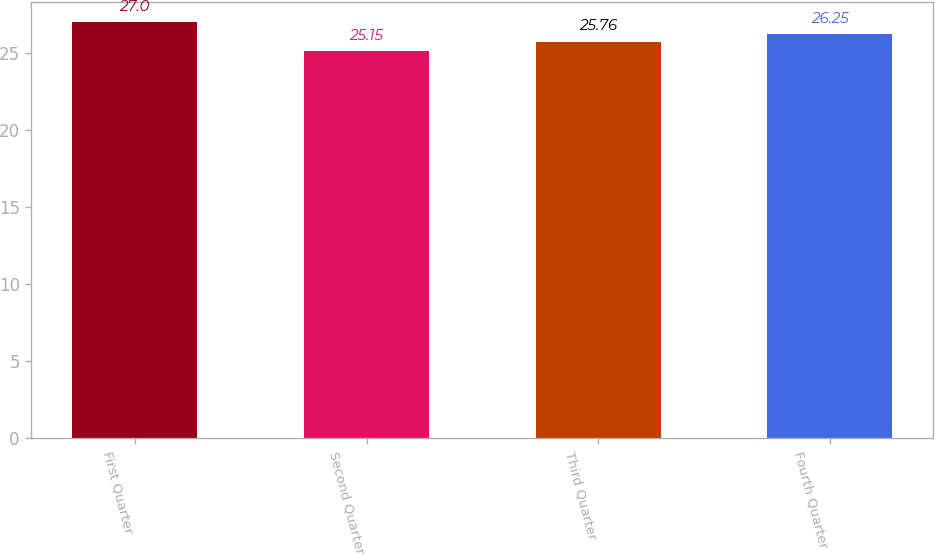Convert chart to OTSL. <chart><loc_0><loc_0><loc_500><loc_500><bar_chart><fcel>First Quarter<fcel>Second Quarter<fcel>Third Quarter<fcel>Fourth Quarter<nl><fcel>27<fcel>25.15<fcel>25.76<fcel>26.25<nl></chart> 